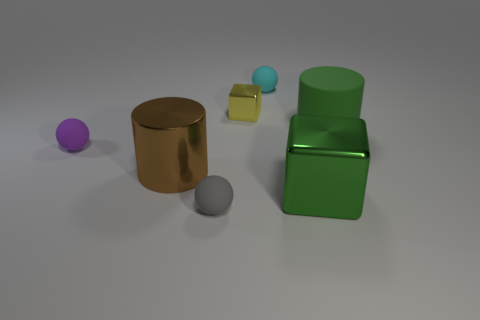How would you describe the arrangement and colors of the objects presented? The objects are arranged in a staggered form, which creates a sense of depth. They exhibit a variety of colors: the leftmost sphere is purple, the central cylindrical object is bronze, the cube is a pale yellow with a hint of blue, and the double-stack object to the far right is a vibrant green. The arrangement and colors add visual interest to the composition. 